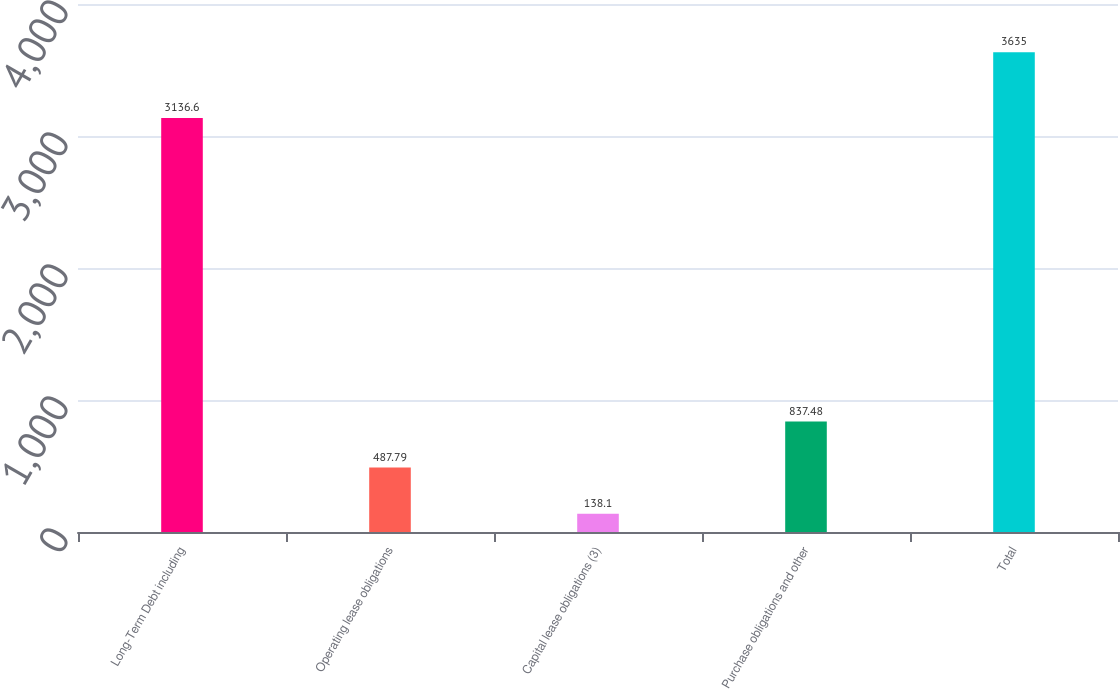Convert chart to OTSL. <chart><loc_0><loc_0><loc_500><loc_500><bar_chart><fcel>Long-Term Debt including<fcel>Operating lease obligations<fcel>Capital lease obligations (3)<fcel>Purchase obligations and other<fcel>Total<nl><fcel>3136.6<fcel>487.79<fcel>138.1<fcel>837.48<fcel>3635<nl></chart> 